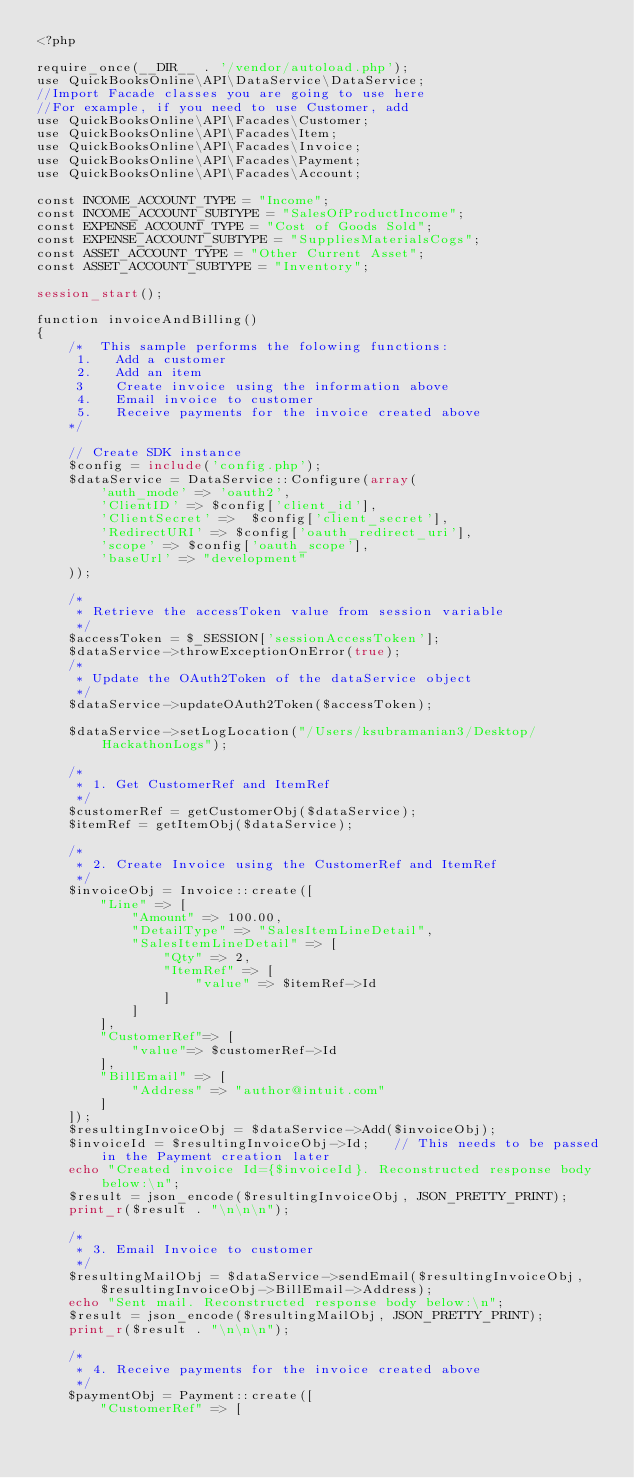Convert code to text. <code><loc_0><loc_0><loc_500><loc_500><_PHP_><?php

require_once(__DIR__ . '/vendor/autoload.php');
use QuickBooksOnline\API\DataService\DataService;
//Import Facade classes you are going to use here
//For example, if you need to use Customer, add
use QuickBooksOnline\API\Facades\Customer;
use QuickBooksOnline\API\Facades\Item;
use QuickBooksOnline\API\Facades\Invoice;
use QuickBooksOnline\API\Facades\Payment;
use QuickBooksOnline\API\Facades\Account;

const INCOME_ACCOUNT_TYPE = "Income";
const INCOME_ACCOUNT_SUBTYPE = "SalesOfProductIncome";
const EXPENSE_ACCOUNT_TYPE = "Cost of Goods Sold";
const EXPENSE_ACCOUNT_SUBTYPE = "SuppliesMaterialsCogs";
const ASSET_ACCOUNT_TYPE = "Other Current Asset";
const ASSET_ACCOUNT_SUBTYPE = "Inventory";

session_start();

function invoiceAndBilling()
{
    /*  This sample performs the folowing functions:
     1.   Add a customer
     2.   Add an item
     3    Create invoice using the information above
     4.   Email invoice to customer
     5.   Receive payments for the invoice created above
    */

    // Create SDK instance
    $config = include('config.php');
    $dataService = DataService::Configure(array(
        'auth_mode' => 'oauth2',
        'ClientID' => $config['client_id'],
        'ClientSecret' =>  $config['client_secret'],
        'RedirectURI' => $config['oauth_redirect_uri'],
        'scope' => $config['oauth_scope'],
        'baseUrl' => "development"
    ));

    /*
     * Retrieve the accessToken value from session variable
     */
    $accessToken = $_SESSION['sessionAccessToken'];
    $dataService->throwExceptionOnError(true);
    /*
     * Update the OAuth2Token of the dataService object
     */
    $dataService->updateOAuth2Token($accessToken);

    $dataService->setLogLocation("/Users/ksubramanian3/Desktop/HackathonLogs");

    /*
     * 1. Get CustomerRef and ItemRef
     */
    $customerRef = getCustomerObj($dataService);
    $itemRef = getItemObj($dataService);

    /*
     * 2. Create Invoice using the CustomerRef and ItemRef
     */
    $invoiceObj = Invoice::create([
        "Line" => [
            "Amount" => 100.00,
            "DetailType" => "SalesItemLineDetail",
            "SalesItemLineDetail" => [
                "Qty" => 2,
                "ItemRef" => [
                    "value" => $itemRef->Id
                ]
            ]
        ],
        "CustomerRef"=> [
            "value"=> $customerRef->Id
        ],
        "BillEmail" => [
            "Address" => "author@intuit.com"
        ]
    ]);
    $resultingInvoiceObj = $dataService->Add($invoiceObj);
    $invoiceId = $resultingInvoiceObj->Id;   // This needs to be passed in the Payment creation later
    echo "Created invoice Id={$invoiceId}. Reconstructed response body below:\n";
    $result = json_encode($resultingInvoiceObj, JSON_PRETTY_PRINT);
    print_r($result . "\n\n\n");

    /*
     * 3. Email Invoice to customer
     */
    $resultingMailObj = $dataService->sendEmail($resultingInvoiceObj,
        $resultingInvoiceObj->BillEmail->Address);
    echo "Sent mail. Reconstructed response body below:\n";
    $result = json_encode($resultingMailObj, JSON_PRETTY_PRINT);
    print_r($result . "\n\n\n");

    /*
     * 4. Receive payments for the invoice created above
     */
    $paymentObj = Payment::create([
        "CustomerRef" => [</code> 